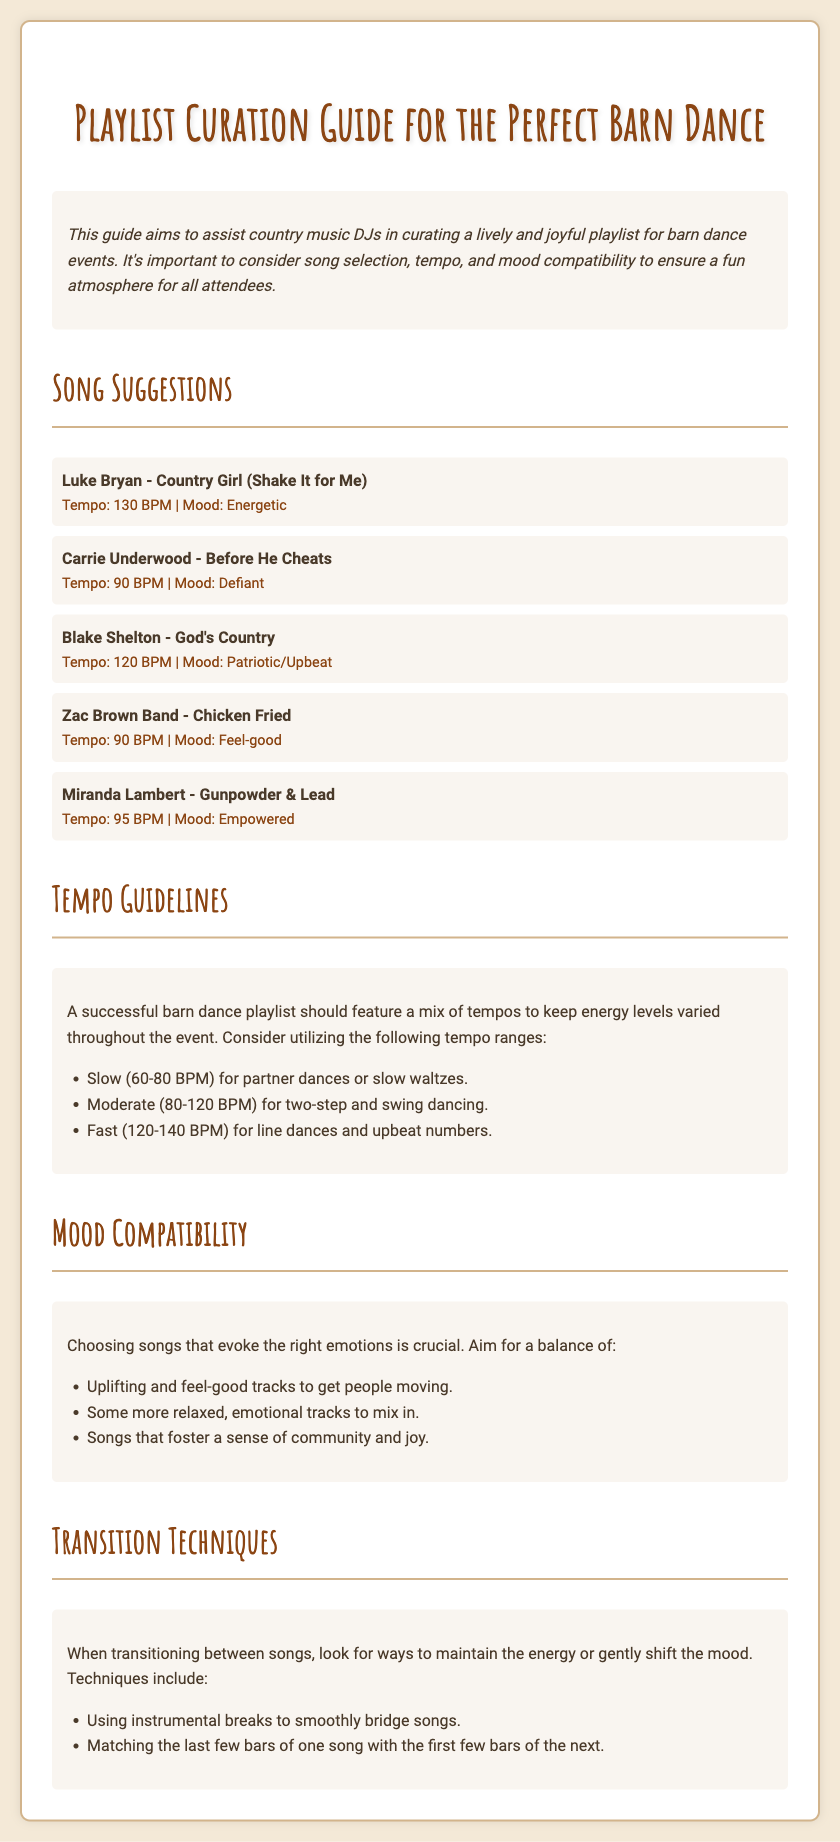What is the title of the document? The title is declared in the head of the HTML document.
Answer: Playlist Curation Guide for the Perfect Barn Dance What is the tempo of "Country Girl (Shake It for Me)"? The tempo is mentioned in the song suggestion list under this song title.
Answer: 130 BPM What mood is associated with "Before He Cheats"? The mood is indicated alongside the song title in the document.
Answer: Defiant What tempo range is suggested for slow dances? The tempo for slow dances is provided in the tempo guidelines section.
Answer: 60-80 BPM Name a song that evokes a feel-good mood. The document lists songs with their corresponding moods, so it can be found in the song suggestions.
Answer: Chicken Fried What techniques are recommended for transitioning between songs? The document provides specific techniques in the transition techniques section.
Answer: Instrumental breaks How many songs are listed in the song suggestions? The number of songs can be counted from the song list in the document.
Answer: 5 What should the mood compatibility focus on? The document outlines the focus for mood compatibility in a specific section.
Answer: Balance of emotions What is the recommended tempo range for line dances? The document includes specific tempo ranges, so the information can be retrieved from that section.
Answer: 120-140 BPM 